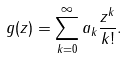Convert formula to latex. <formula><loc_0><loc_0><loc_500><loc_500>g ( z ) = \sum _ { k = 0 } ^ { \infty } a _ { k } \frac { z ^ { k } } { k ! } .</formula> 